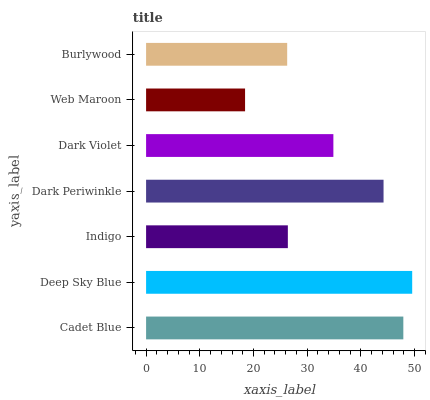Is Web Maroon the minimum?
Answer yes or no. Yes. Is Deep Sky Blue the maximum?
Answer yes or no. Yes. Is Indigo the minimum?
Answer yes or no. No. Is Indigo the maximum?
Answer yes or no. No. Is Deep Sky Blue greater than Indigo?
Answer yes or no. Yes. Is Indigo less than Deep Sky Blue?
Answer yes or no. Yes. Is Indigo greater than Deep Sky Blue?
Answer yes or no. No. Is Deep Sky Blue less than Indigo?
Answer yes or no. No. Is Dark Violet the high median?
Answer yes or no. Yes. Is Dark Violet the low median?
Answer yes or no. Yes. Is Indigo the high median?
Answer yes or no. No. Is Dark Periwinkle the low median?
Answer yes or no. No. 